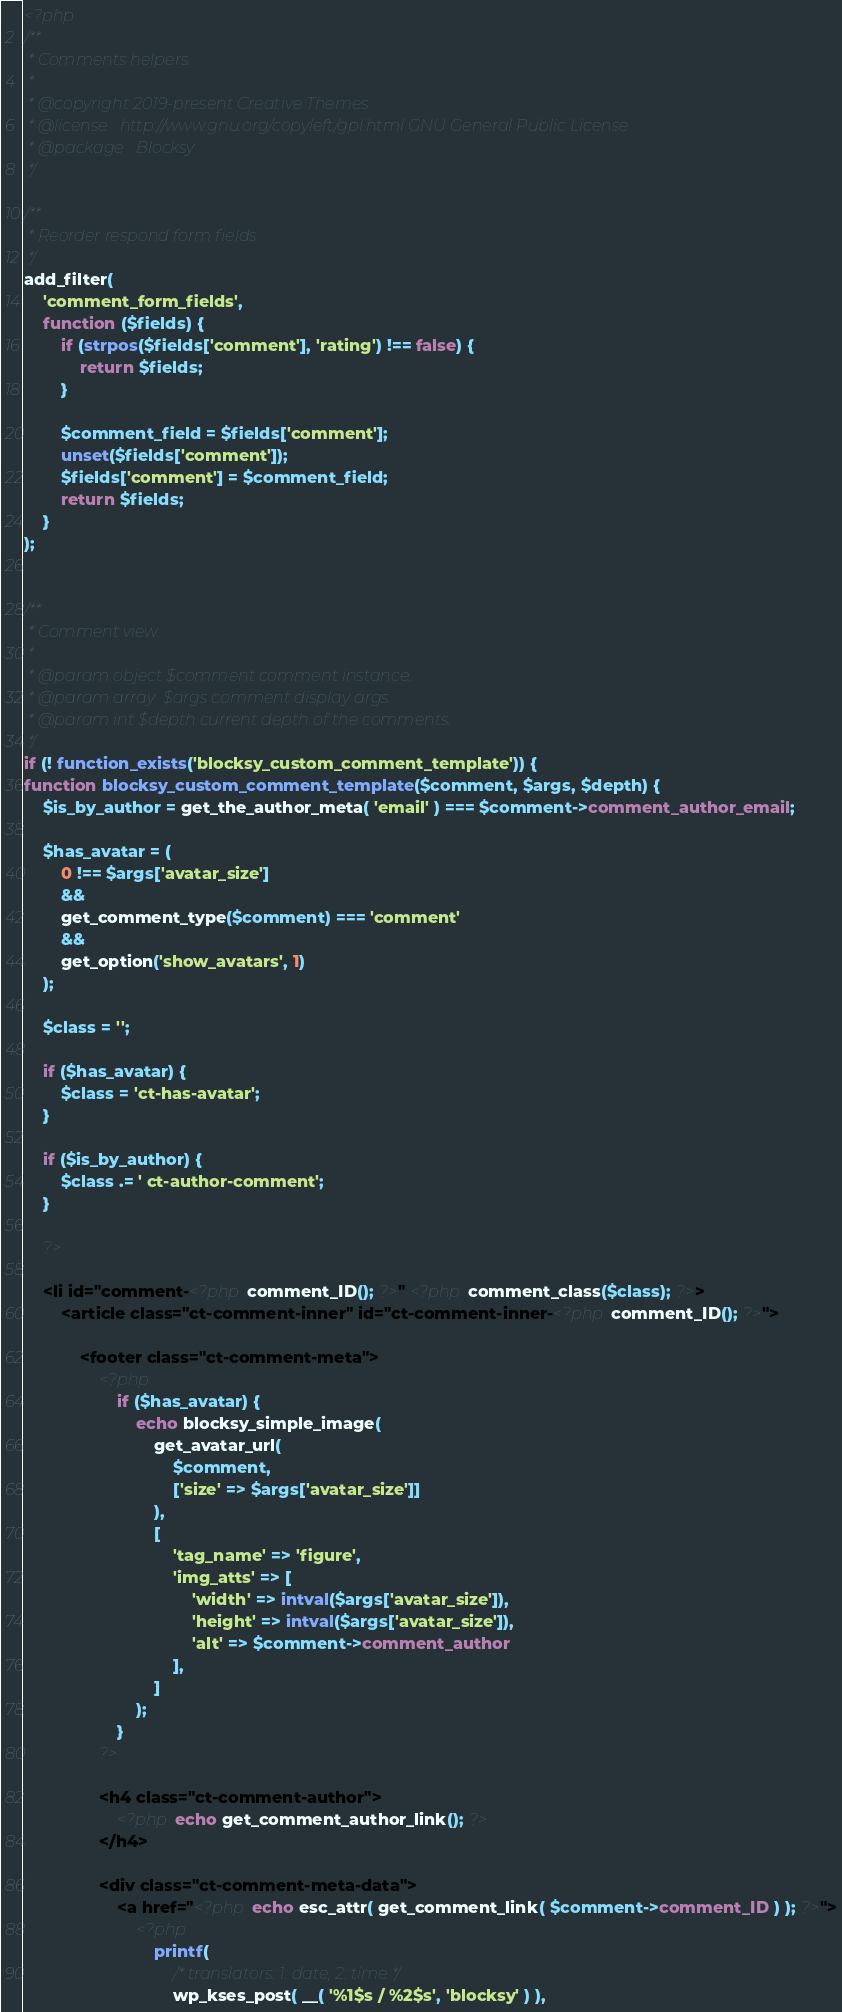Convert code to text. <code><loc_0><loc_0><loc_500><loc_500><_PHP_><?php
/**
 * Comments helpers.
 *
 * @copyright 2019-present Creative Themes
 * @license   http://www.gnu.org/copyleft/gpl.html GNU General Public License
 * @package   Blocksy
 */

/**
 * Reorder respond form fields
 */
add_filter(
	'comment_form_fields',
	function ($fields) {
		if (strpos($fields['comment'], 'rating') !== false) {
			return $fields;
		}

		$comment_field = $fields['comment'];
		unset($fields['comment']);
		$fields['comment'] = $comment_field;
		return $fields;
	}
);


/**
 * Comment view.
 *
 * @param object $comment comment instance.
 * @param array  $args comment display args.
 * @param int $depth current depth of the comments.
 */
if (! function_exists('blocksy_custom_comment_template')) {
function blocksy_custom_comment_template($comment, $args, $depth) {
	$is_by_author = get_the_author_meta( 'email' ) === $comment->comment_author_email;

	$has_avatar = (
		0 !== $args['avatar_size']
		&&
		get_comment_type($comment) === 'comment'
		&&
		get_option('show_avatars', 1)
	);

	$class = '';

	if ($has_avatar) {
		$class = 'ct-has-avatar';
	}

	if ($is_by_author) {
		$class .= ' ct-author-comment';
	}

	?>

	<li id="comment-<?php comment_ID(); ?>" <?php comment_class($class); ?>>
		<article class="ct-comment-inner" id="ct-comment-inner-<?php comment_ID(); ?>">

			<footer class="ct-comment-meta">
				<?php
					if ($has_avatar) {
						echo blocksy_simple_image(
							get_avatar_url(
								$comment,
								['size' => $args['avatar_size']]
							),
							[
								'tag_name' => 'figure',
								'img_atts' => [
									'width' => intval($args['avatar_size']),
									'height' => intval($args['avatar_size']),
									'alt' => $comment->comment_author
								],
							]
						);
					}
				?>

				<h4 class="ct-comment-author">
					<?php echo get_comment_author_link(); ?>
				</h4>

				<div class="ct-comment-meta-data">
					<a href="<?php echo esc_attr( get_comment_link( $comment->comment_ID ) ); ?>">
						<?php
							printf(
								/* translators: 1: date, 2: time */
								wp_kses_post( __( '%1$s / %2$s', 'blocksy' ) ),</code> 